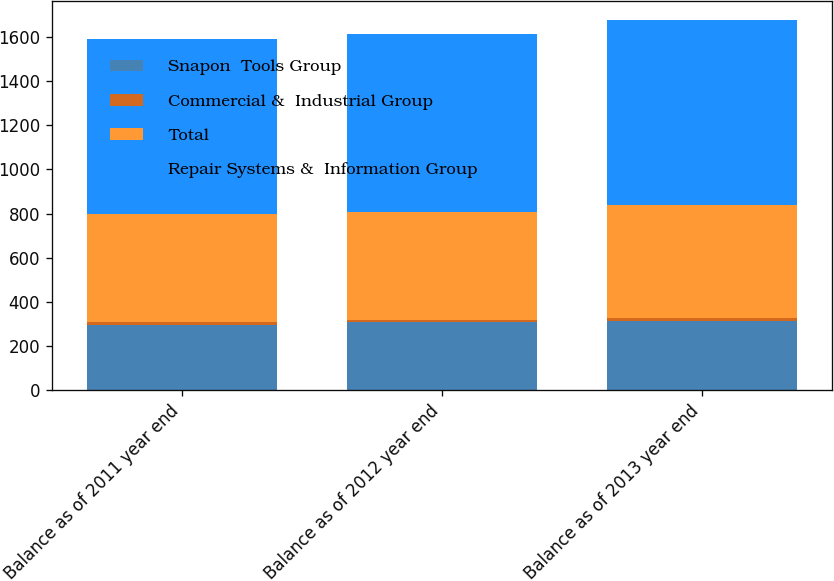Convert chart. <chart><loc_0><loc_0><loc_500><loc_500><stacked_bar_chart><ecel><fcel>Balance as of 2011 year end<fcel>Balance as of 2012 year end<fcel>Balance as of 2013 year end<nl><fcel>Snapon  Tools Group<fcel>297<fcel>306.9<fcel>312.5<nl><fcel>Commercial &  Industrial Group<fcel>12.5<fcel>12.5<fcel>12.5<nl><fcel>Total<fcel>486.3<fcel>488<fcel>513.8<nl><fcel>Repair Systems &  Information Group<fcel>795.8<fcel>807.4<fcel>838.8<nl></chart> 